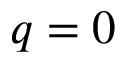<formula> <loc_0><loc_0><loc_500><loc_500>q = 0</formula> 